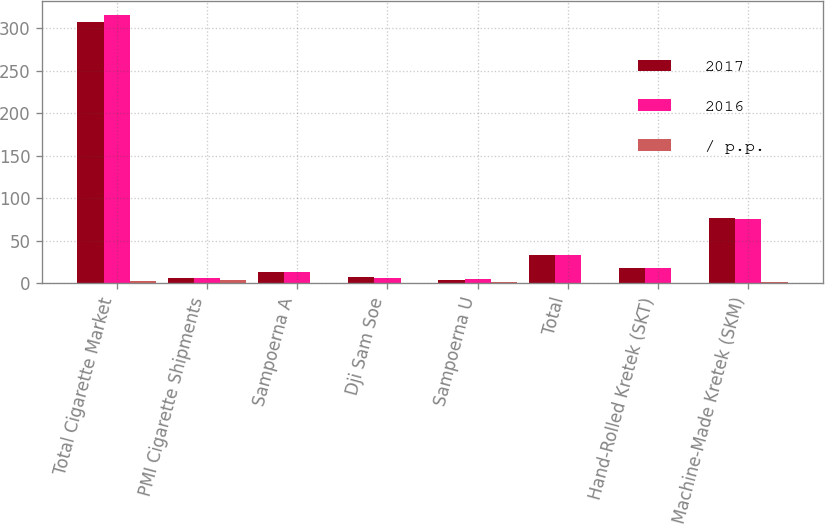Convert chart. <chart><loc_0><loc_0><loc_500><loc_500><stacked_bar_chart><ecel><fcel>Total Cigarette Market<fcel>PMI Cigarette Shipments<fcel>Sampoerna A<fcel>Dji Sam Soe<fcel>Sampoerna U<fcel>Total<fcel>Hand-Rolled Kretek (SKT)<fcel>Machine-Made Kretek (SKM)<nl><fcel>2017<fcel>307.4<fcel>6.95<fcel>13.8<fcel>7.4<fcel>4.1<fcel>33<fcel>17.6<fcel>77.2<nl><fcel>2016<fcel>315.6<fcel>6.95<fcel>14<fcel>6.5<fcel>5.2<fcel>33.4<fcel>18.2<fcel>75.8<nl><fcel>/ p.p.<fcel>2.6<fcel>4<fcel>0.2<fcel>0.9<fcel>1.1<fcel>0.4<fcel>0.6<fcel>1.4<nl></chart> 